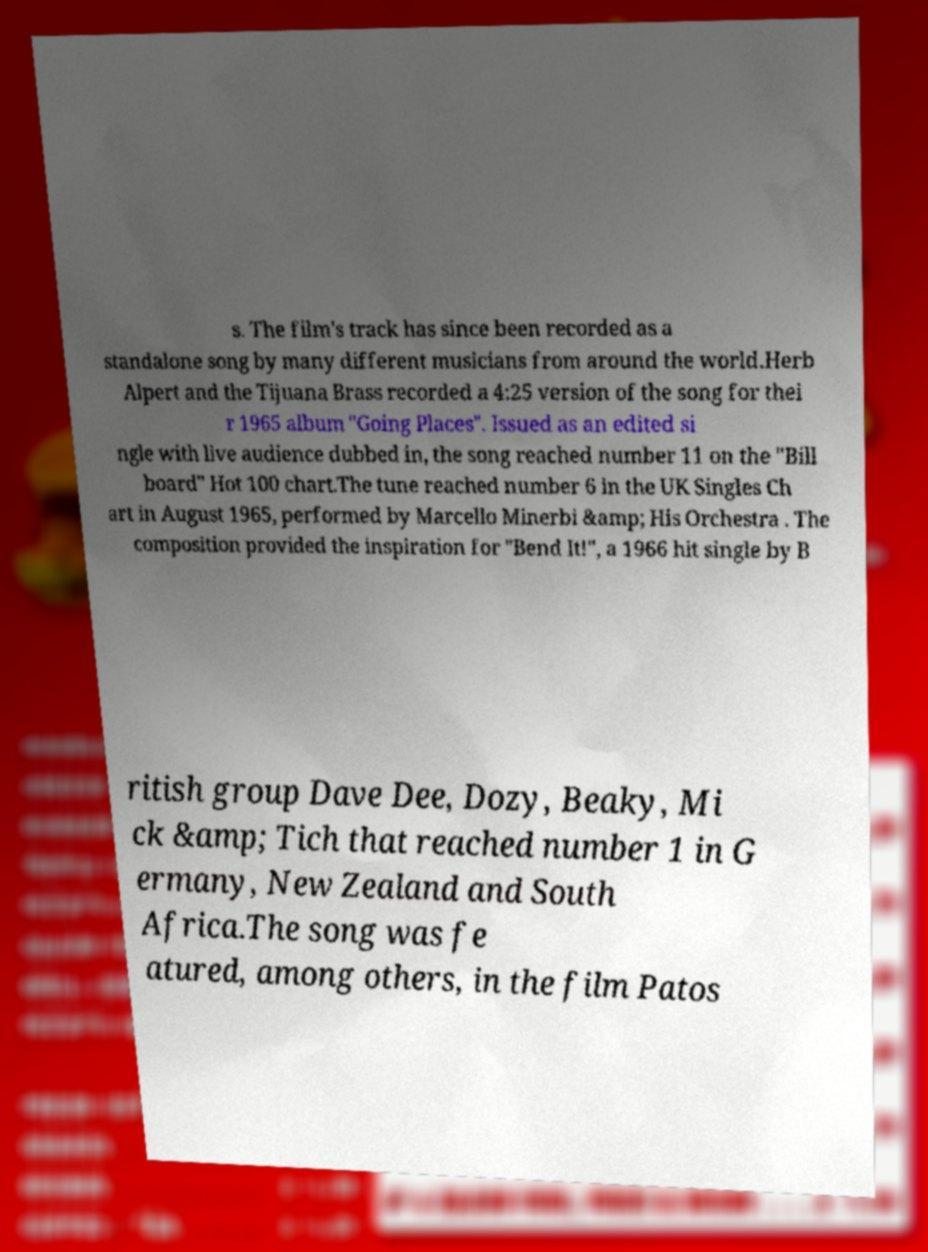Please read and relay the text visible in this image. What does it say? s. The film's track has since been recorded as a standalone song by many different musicians from around the world.Herb Alpert and the Tijuana Brass recorded a 4:25 version of the song for thei r 1965 album "Going Places". Issued as an edited si ngle with live audience dubbed in, the song reached number 11 on the "Bill board" Hot 100 chart.The tune reached number 6 in the UK Singles Ch art in August 1965, performed by Marcello Minerbi &amp; His Orchestra . The composition provided the inspiration for "Bend It!", a 1966 hit single by B ritish group Dave Dee, Dozy, Beaky, Mi ck &amp; Tich that reached number 1 in G ermany, New Zealand and South Africa.The song was fe atured, among others, in the film Patos 